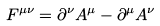Convert formula to latex. <formula><loc_0><loc_0><loc_500><loc_500>F ^ { \mu \nu } = \partial ^ { \nu } A ^ { \mu } - \partial ^ { \mu } A ^ { \nu }</formula> 